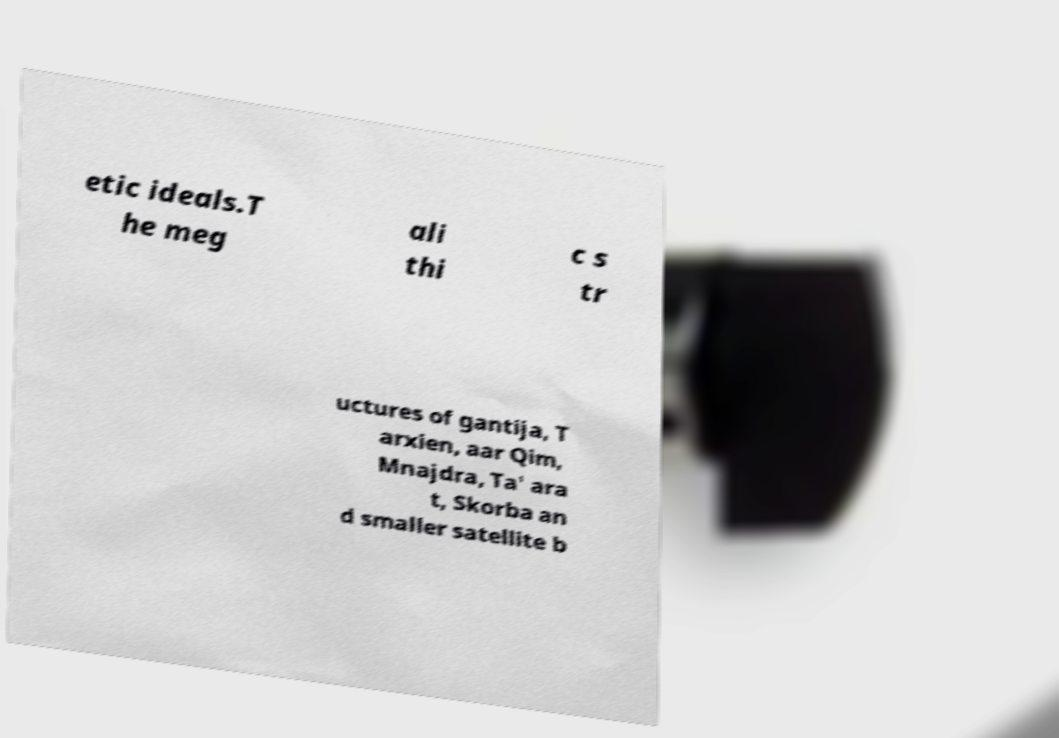For documentation purposes, I need the text within this image transcribed. Could you provide that? etic ideals.T he meg ali thi c s tr uctures of gantija, T arxien, aar Qim, Mnajdra, Ta' ara t, Skorba an d smaller satellite b 